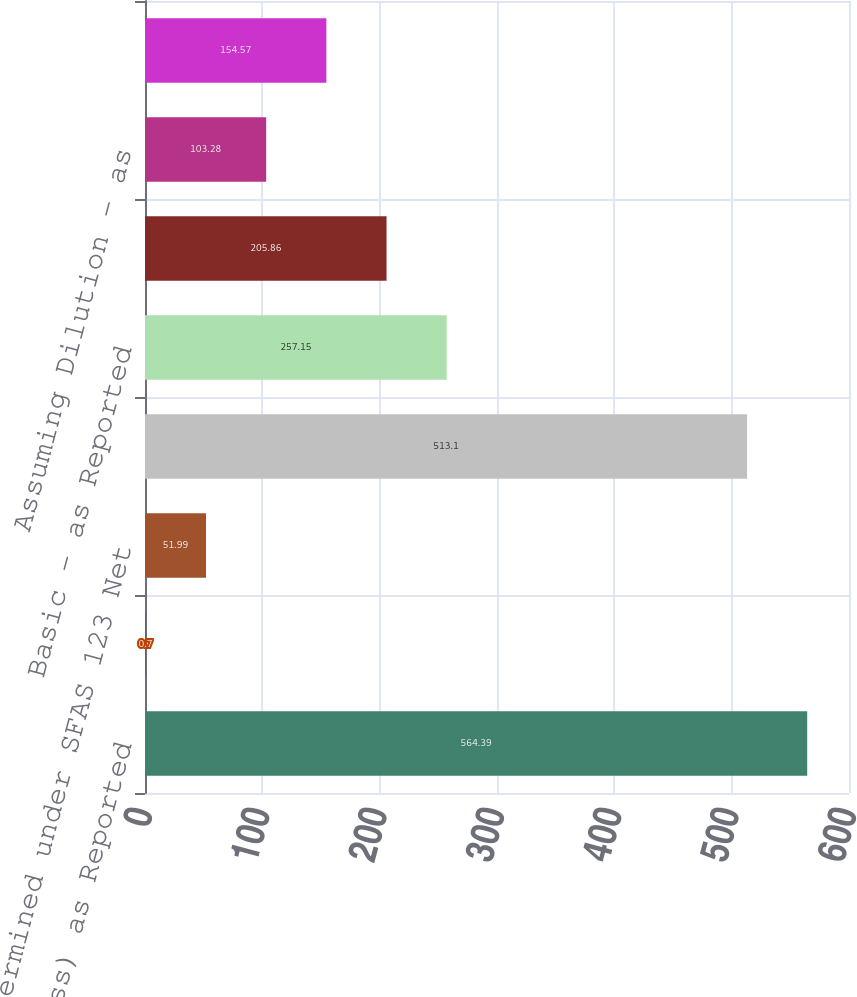Convert chart. <chart><loc_0><loc_0><loc_500><loc_500><bar_chart><fcel>Net Income (Loss) as Reported<fcel>Net of Tax<fcel>Determined under SFAS 123 Net<fcel>Pro Forma Net Income (Loss)<fcel>Basic - as Reported<fcel>Basic - Pro Forma<fcel>Assuming Dilution - as<fcel>Assuming Dilution - Pro Forma<nl><fcel>564.39<fcel>0.7<fcel>51.99<fcel>513.1<fcel>257.15<fcel>205.86<fcel>103.28<fcel>154.57<nl></chart> 